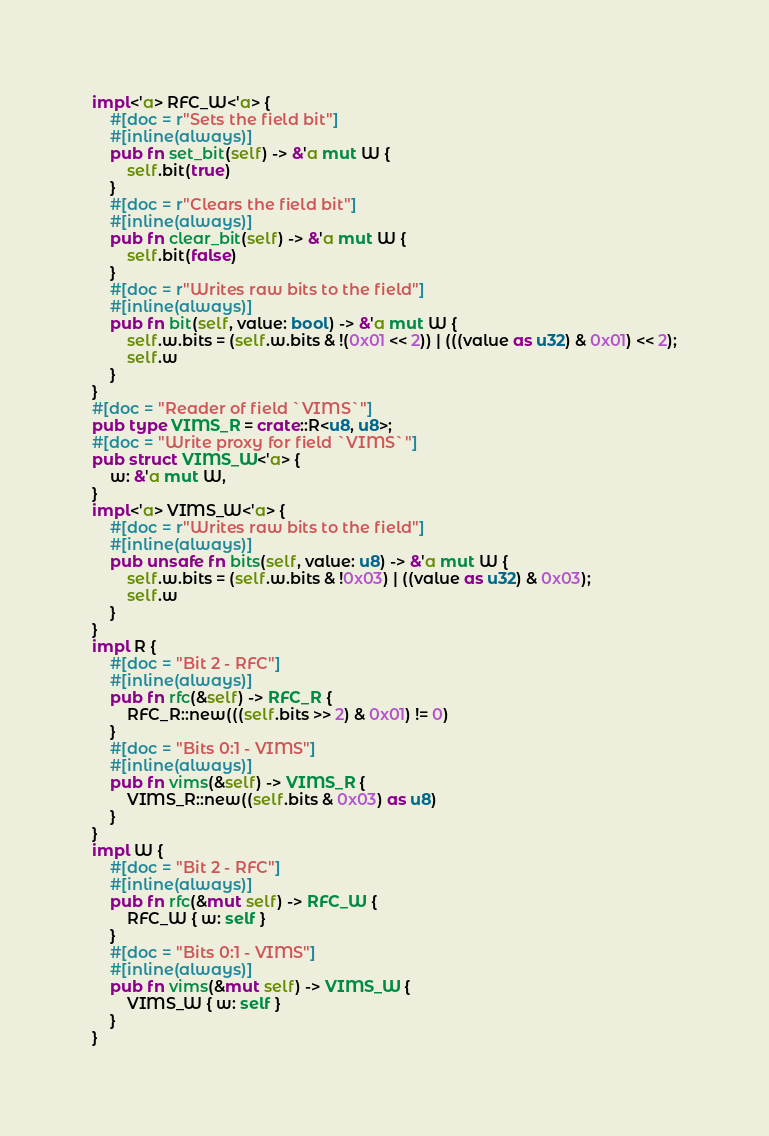<code> <loc_0><loc_0><loc_500><loc_500><_Rust_>impl<'a> RFC_W<'a> {
    #[doc = r"Sets the field bit"]
    #[inline(always)]
    pub fn set_bit(self) -> &'a mut W {
        self.bit(true)
    }
    #[doc = r"Clears the field bit"]
    #[inline(always)]
    pub fn clear_bit(self) -> &'a mut W {
        self.bit(false)
    }
    #[doc = r"Writes raw bits to the field"]
    #[inline(always)]
    pub fn bit(self, value: bool) -> &'a mut W {
        self.w.bits = (self.w.bits & !(0x01 << 2)) | (((value as u32) & 0x01) << 2);
        self.w
    }
}
#[doc = "Reader of field `VIMS`"]
pub type VIMS_R = crate::R<u8, u8>;
#[doc = "Write proxy for field `VIMS`"]
pub struct VIMS_W<'a> {
    w: &'a mut W,
}
impl<'a> VIMS_W<'a> {
    #[doc = r"Writes raw bits to the field"]
    #[inline(always)]
    pub unsafe fn bits(self, value: u8) -> &'a mut W {
        self.w.bits = (self.w.bits & !0x03) | ((value as u32) & 0x03);
        self.w
    }
}
impl R {
    #[doc = "Bit 2 - RFC"]
    #[inline(always)]
    pub fn rfc(&self) -> RFC_R {
        RFC_R::new(((self.bits >> 2) & 0x01) != 0)
    }
    #[doc = "Bits 0:1 - VIMS"]
    #[inline(always)]
    pub fn vims(&self) -> VIMS_R {
        VIMS_R::new((self.bits & 0x03) as u8)
    }
}
impl W {
    #[doc = "Bit 2 - RFC"]
    #[inline(always)]
    pub fn rfc(&mut self) -> RFC_W {
        RFC_W { w: self }
    }
    #[doc = "Bits 0:1 - VIMS"]
    #[inline(always)]
    pub fn vims(&mut self) -> VIMS_W {
        VIMS_W { w: self }
    }
}
</code> 